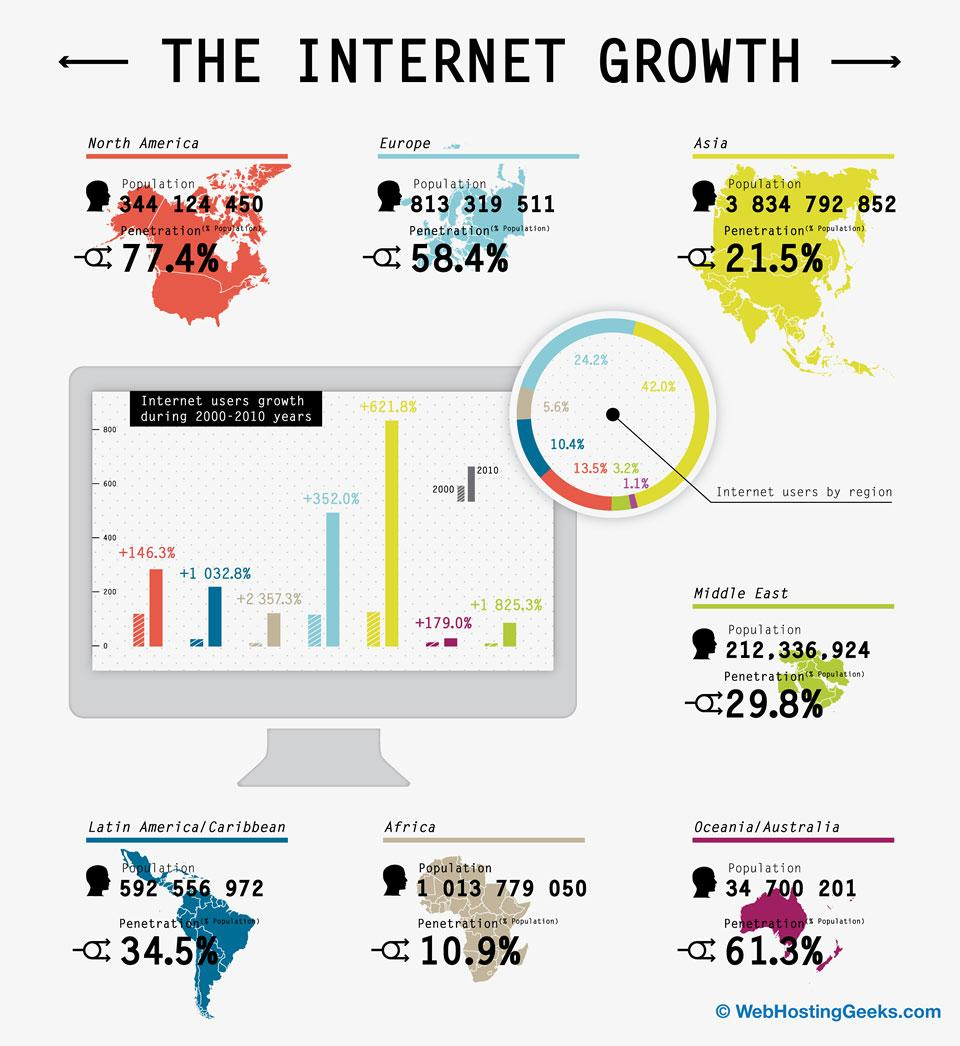Point out several critical features in this image. North America is ahead of Europe in terms of penetration by 19%. 